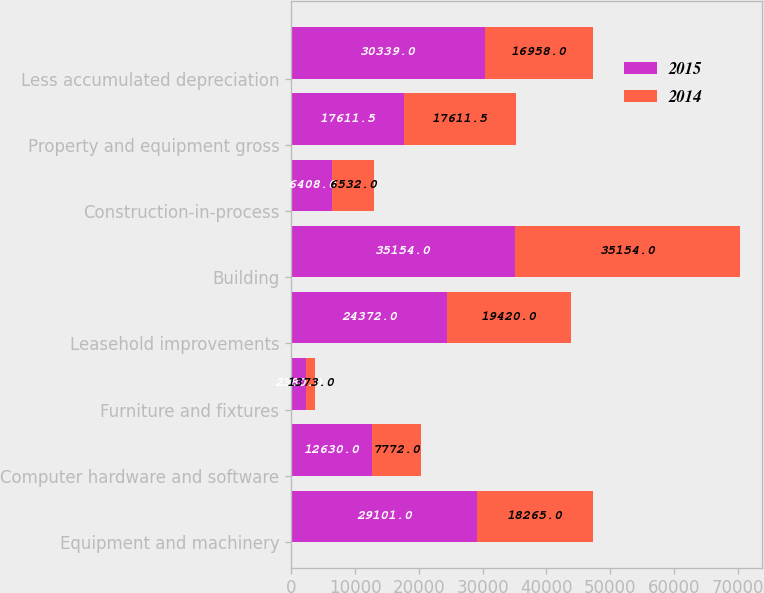<chart> <loc_0><loc_0><loc_500><loc_500><stacked_bar_chart><ecel><fcel>Equipment and machinery<fcel>Computer hardware and software<fcel>Furniture and fixtures<fcel>Leasehold improvements<fcel>Building<fcel>Construction-in-process<fcel>Property and equipment gross<fcel>Less accumulated depreciation<nl><fcel>2015<fcel>29101<fcel>12630<fcel>2380<fcel>24372<fcel>35154<fcel>6408<fcel>17611.5<fcel>30339<nl><fcel>2014<fcel>18265<fcel>7772<fcel>1373<fcel>19420<fcel>35154<fcel>6532<fcel>17611.5<fcel>16958<nl></chart> 